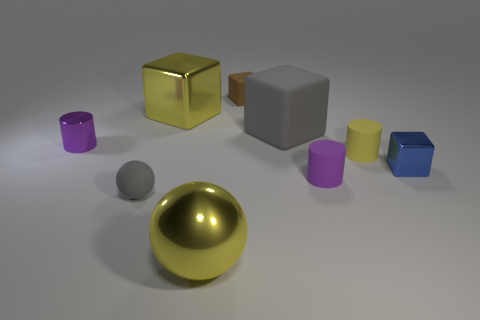Subtract all balls. How many objects are left? 7 Add 5 yellow matte cylinders. How many yellow matte cylinders exist? 6 Subtract 0 purple spheres. How many objects are left? 9 Subtract all small gray matte balls. Subtract all brown things. How many objects are left? 7 Add 7 small yellow rubber things. How many small yellow rubber things are left? 8 